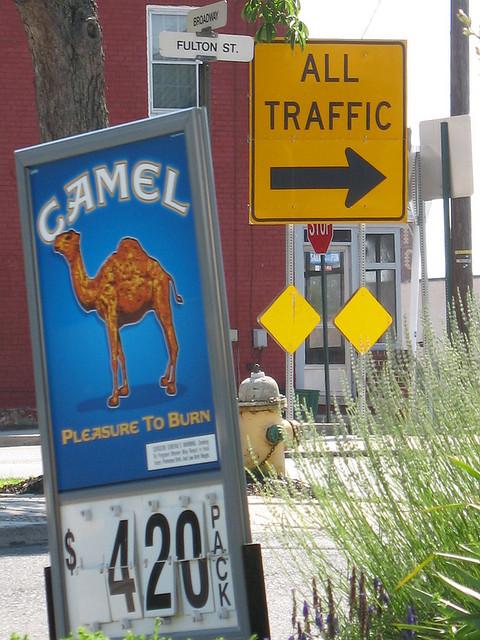How much are the camels?
Keep it brief. $4.20. Which way is the arrow pointing?
Quick response, please. Right. What number is seen?
Give a very brief answer. 420. 